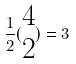<formula> <loc_0><loc_0><loc_500><loc_500>\frac { 1 } { 2 } ( \begin{matrix} 4 \\ 2 \end{matrix} ) = 3</formula> 